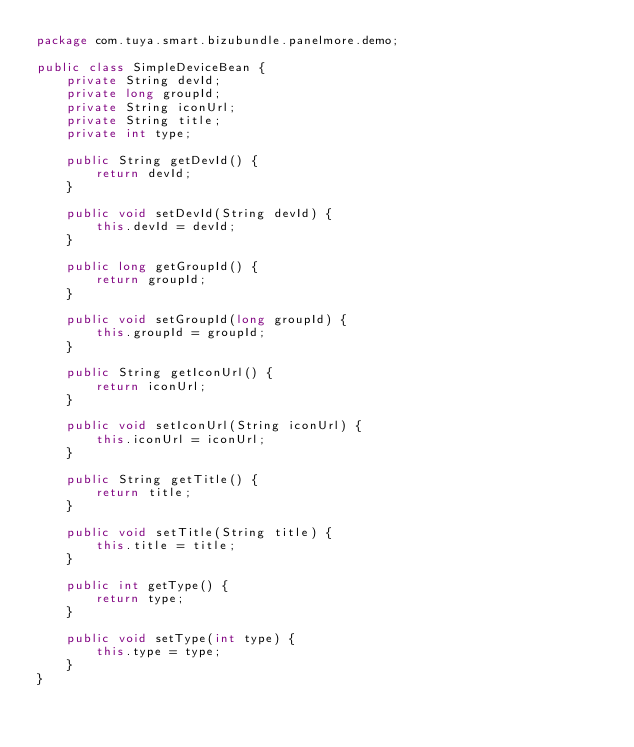<code> <loc_0><loc_0><loc_500><loc_500><_Java_>package com.tuya.smart.bizubundle.panelmore.demo;

public class SimpleDeviceBean {
    private String devId;
    private long groupId;
    private String iconUrl;
    private String title;
    private int type;

    public String getDevId() {
        return devId;
    }

    public void setDevId(String devId) {
        this.devId = devId;
    }

    public long getGroupId() {
        return groupId;
    }

    public void setGroupId(long groupId) {
        this.groupId = groupId;
    }

    public String getIconUrl() {
        return iconUrl;
    }

    public void setIconUrl(String iconUrl) {
        this.iconUrl = iconUrl;
    }

    public String getTitle() {
        return title;
    }

    public void setTitle(String title) {
        this.title = title;
    }

    public int getType() {
        return type;
    }

    public void setType(int type) {
        this.type = type;
    }
}
</code> 